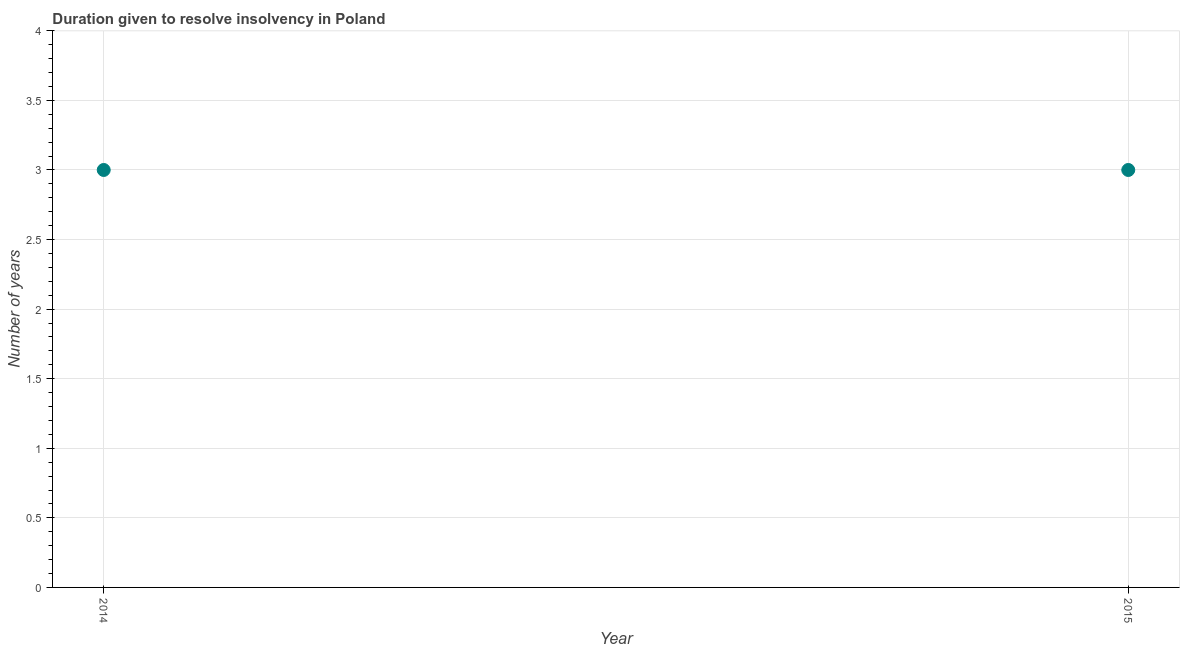What is the number of years to resolve insolvency in 2014?
Provide a succinct answer. 3. Across all years, what is the maximum number of years to resolve insolvency?
Ensure brevity in your answer.  3. Across all years, what is the minimum number of years to resolve insolvency?
Offer a terse response. 3. In which year was the number of years to resolve insolvency maximum?
Your answer should be very brief. 2014. What is the average number of years to resolve insolvency per year?
Your answer should be compact. 3. What is the median number of years to resolve insolvency?
Offer a terse response. 3. Is the number of years to resolve insolvency in 2014 less than that in 2015?
Offer a very short reply. No. How many dotlines are there?
Keep it short and to the point. 1. How many years are there in the graph?
Your response must be concise. 2. Does the graph contain any zero values?
Your answer should be compact. No. Does the graph contain grids?
Your answer should be compact. Yes. What is the title of the graph?
Give a very brief answer. Duration given to resolve insolvency in Poland. What is the label or title of the X-axis?
Provide a succinct answer. Year. What is the label or title of the Y-axis?
Provide a succinct answer. Number of years. What is the Number of years in 2014?
Your response must be concise. 3. 